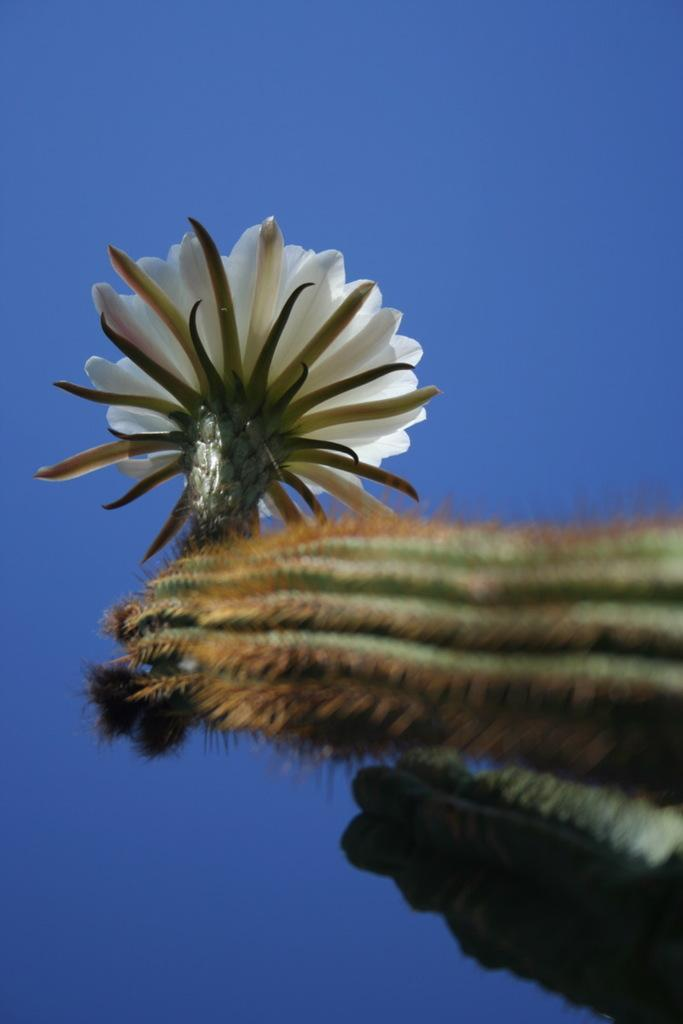What is the main subject in the foreground of the image? There is a flower in the foreground of the image. What color is the object in the background of the image? There is a blue color object in the background of the image. How many spoons can be seen in the image? There are no spoons present in the image. Is there a cactus visible in the image? There is no cactus present in the image. 